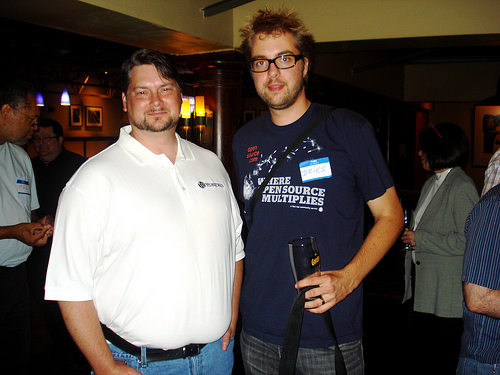<image>
Is there a man on the cup? No. The man is not positioned on the cup. They may be near each other, but the man is not supported by or resting on top of the cup. 